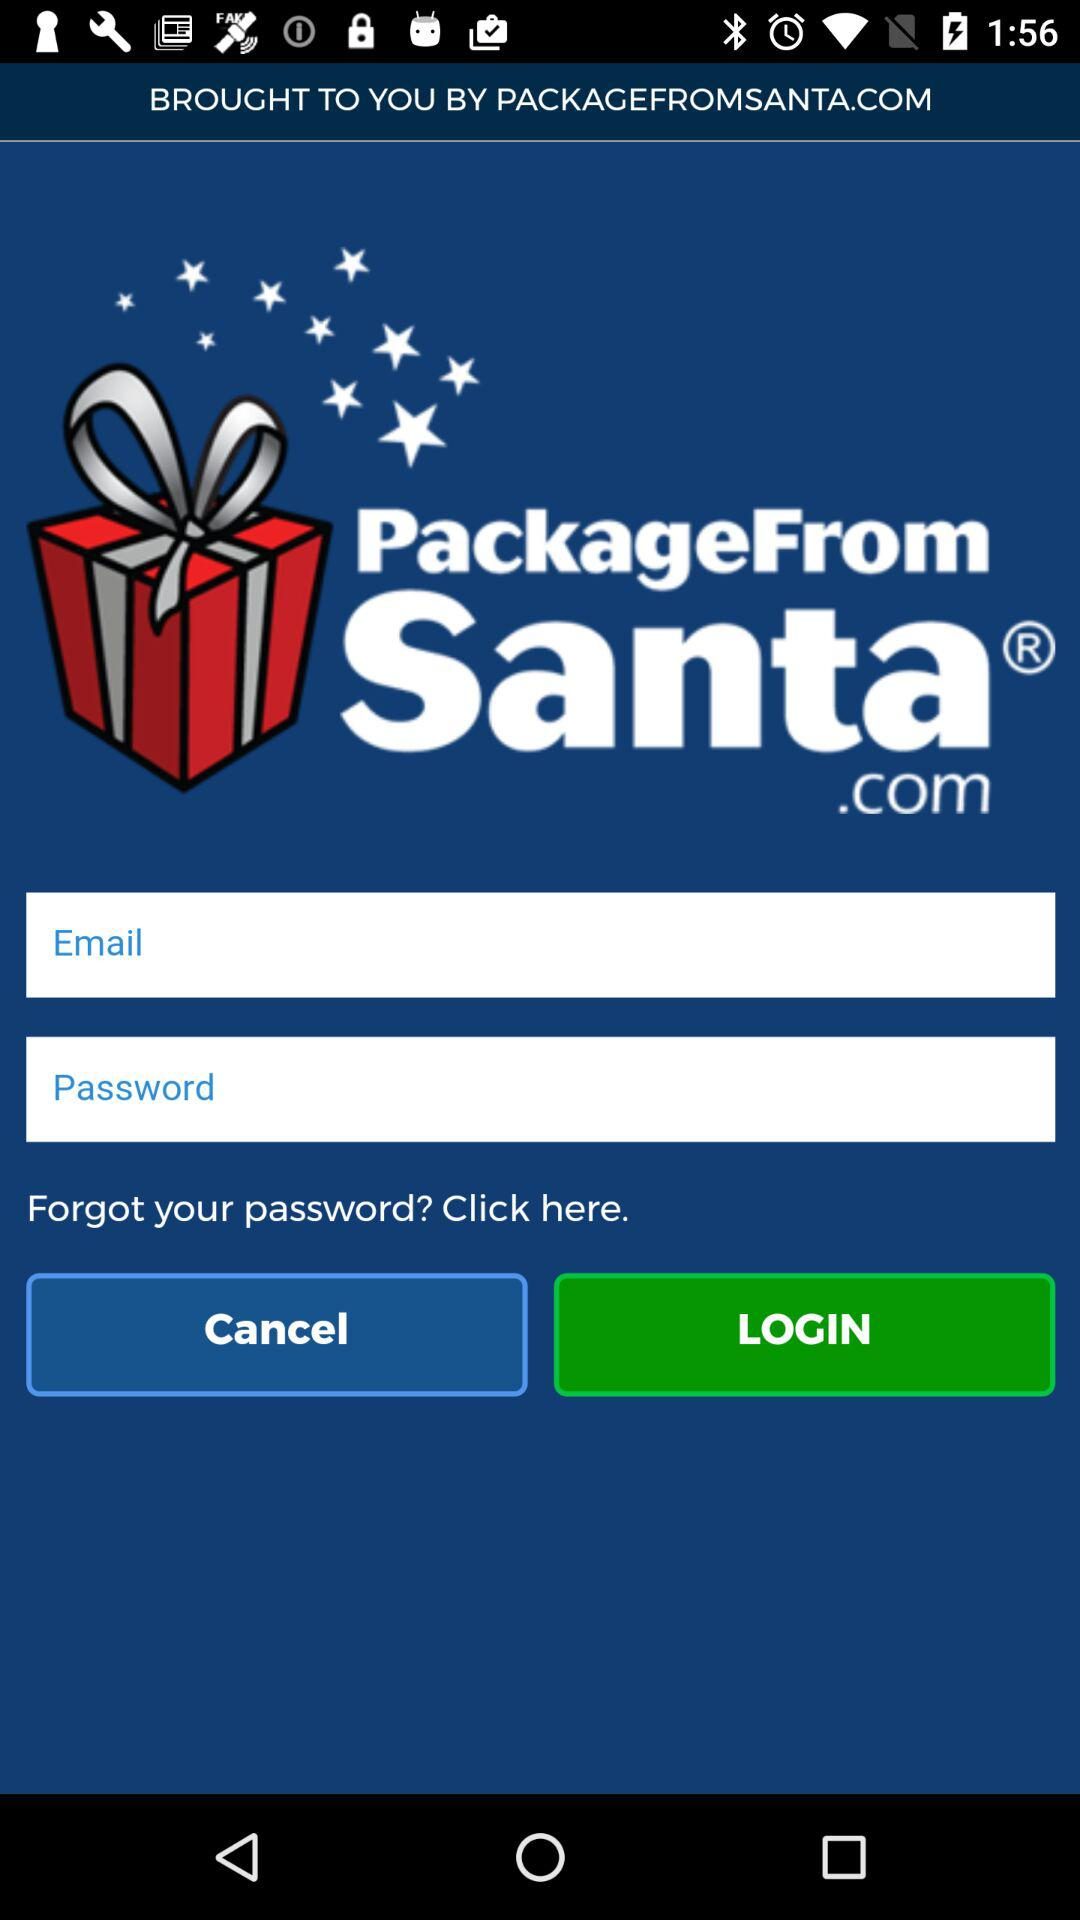What is the name of application?
When the provided information is insufficient, respond with <no answer>. <no answer> 